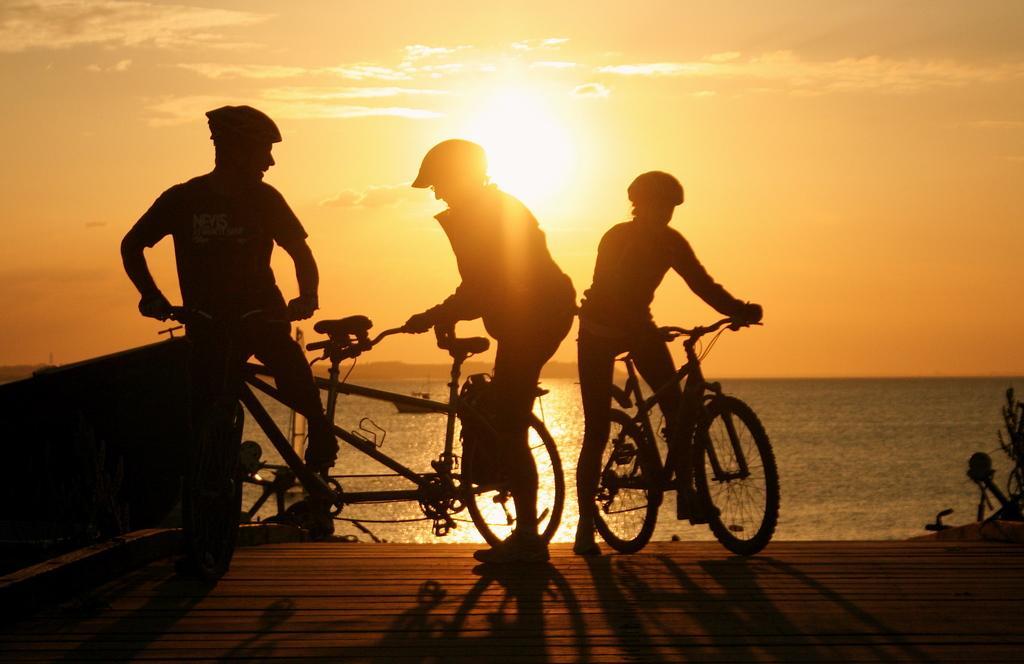Can you describe this image briefly? In this picture we can see three persons wore helmets and holding bicycles with their hands on platform and in background we can see sky, water. 